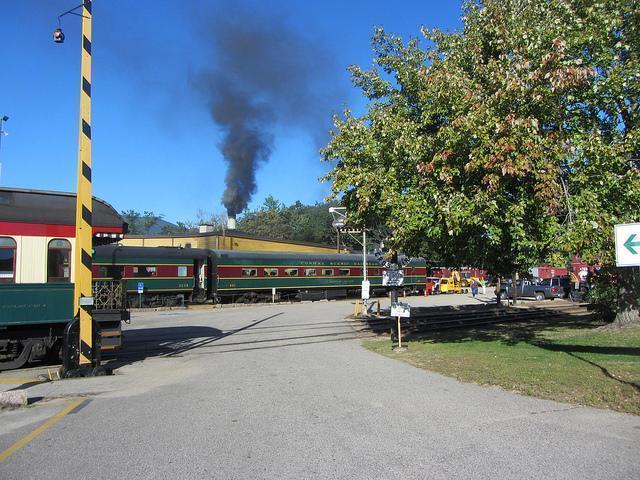In which direction is the train going that is behind the raised arm?
Select the accurate answer and provide explanation: 'Answer: answer
Rationale: rationale.'
Options: Forwards, backwards, nowhere, not train. Answer: nowhere.
Rationale: The train at the station is not going anywhere at the moment. its smoke is going straight up. 